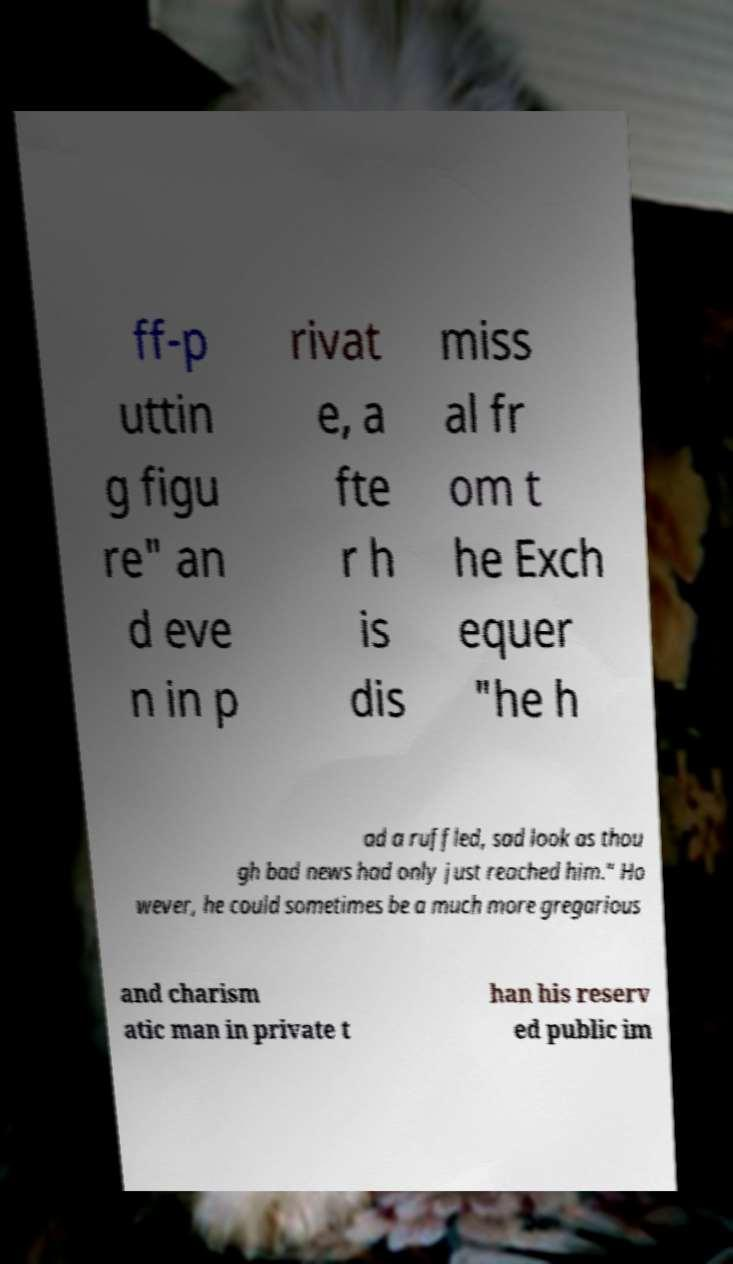Please read and relay the text visible in this image. What does it say? ff-p uttin g figu re" an d eve n in p rivat e, a fte r h is dis miss al fr om t he Exch equer "he h ad a ruffled, sad look as thou gh bad news had only just reached him." Ho wever, he could sometimes be a much more gregarious and charism atic man in private t han his reserv ed public im 